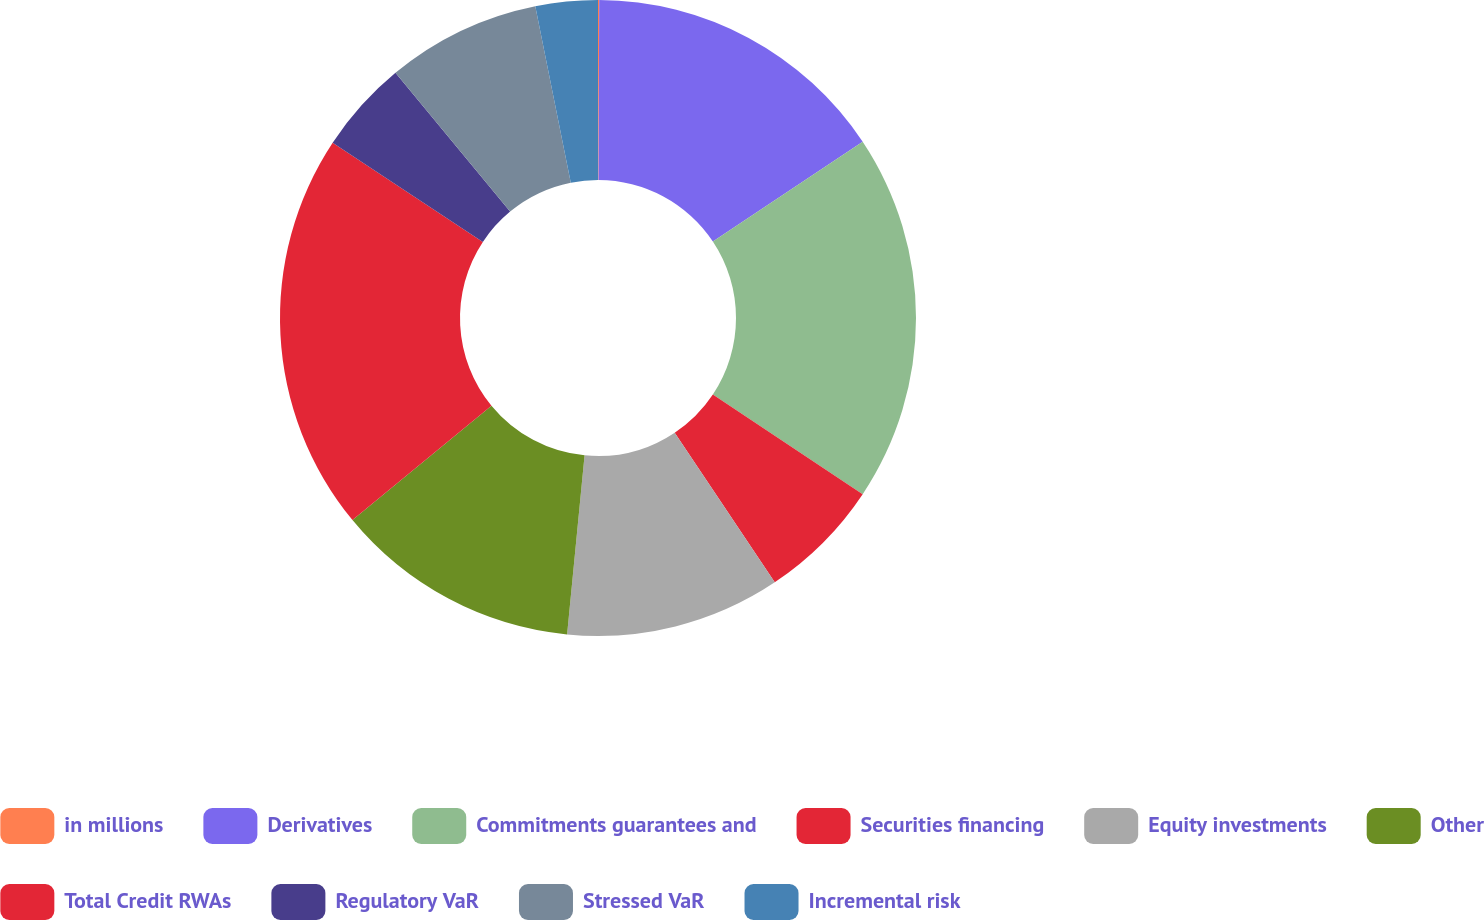<chart> <loc_0><loc_0><loc_500><loc_500><pie_chart><fcel>in millions<fcel>Derivatives<fcel>Commitments guarantees and<fcel>Securities financing<fcel>Equity investments<fcel>Other<fcel>Total Credit RWAs<fcel>Regulatory VaR<fcel>Stressed VaR<fcel>Incremental risk<nl><fcel>0.06%<fcel>15.59%<fcel>18.7%<fcel>6.27%<fcel>10.93%<fcel>12.49%<fcel>20.25%<fcel>4.72%<fcel>7.83%<fcel>3.16%<nl></chart> 